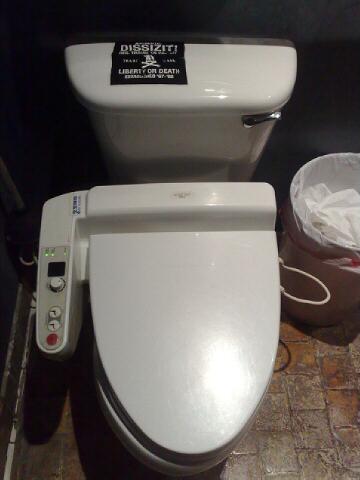Is the toilet seat up?
Short answer required. No. Is this a heated seat?
Give a very brief answer. Yes. Is there a sign on top of the toilet?
Answer briefly. Yes. Is the trash can empty?
Write a very short answer. No. 